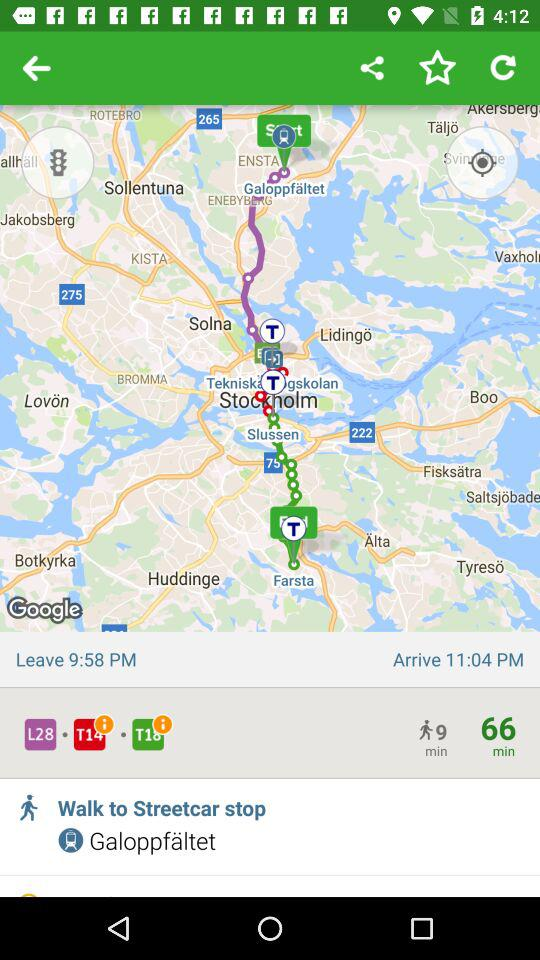What's the total duration? The total duration is 66 minutes. 